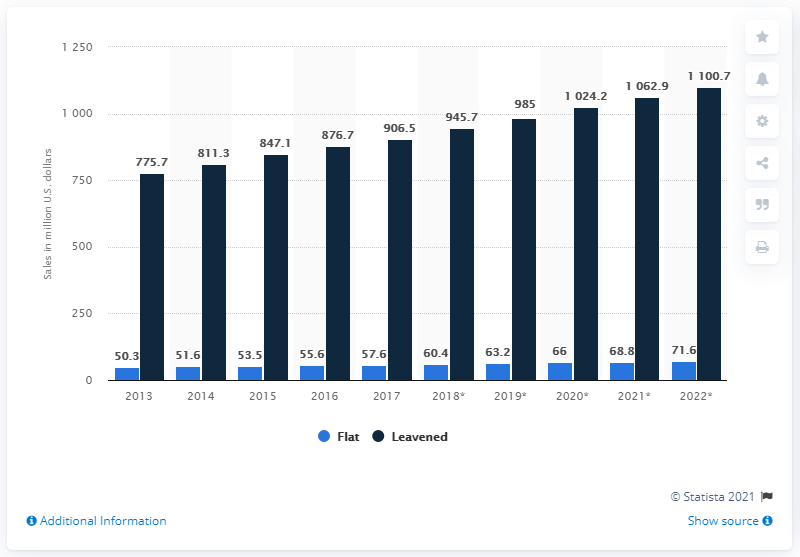Mention a couple of crucial points in this snapshot. Unpackaged bread was first sold in Canada in 2013. In 2017, the retail sales of unpackaged leavened bread in the United States was 906.5 million dollars. The sale of flat bread is expected to reach its highest level in the year 2022. The average sale of leavened bread from 2021 to 2022 was 1081.8 units. 